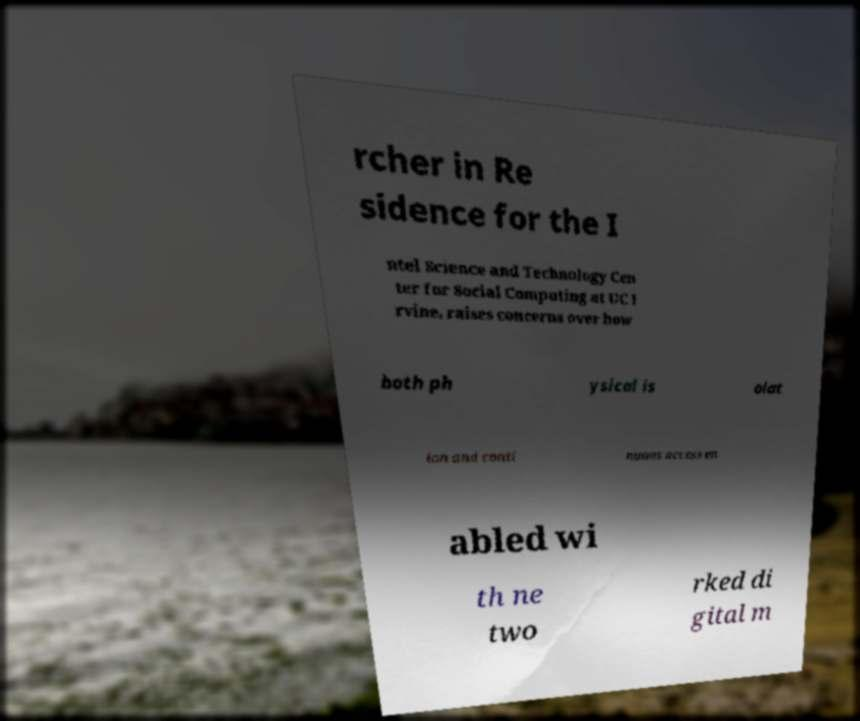There's text embedded in this image that I need extracted. Can you transcribe it verbatim? rcher in Re sidence for the I ntel Science and Technology Cen ter for Social Computing at UC I rvine, raises concerns over how both ph ysical is olat ion and conti nuous access en abled wi th ne two rked di gital m 